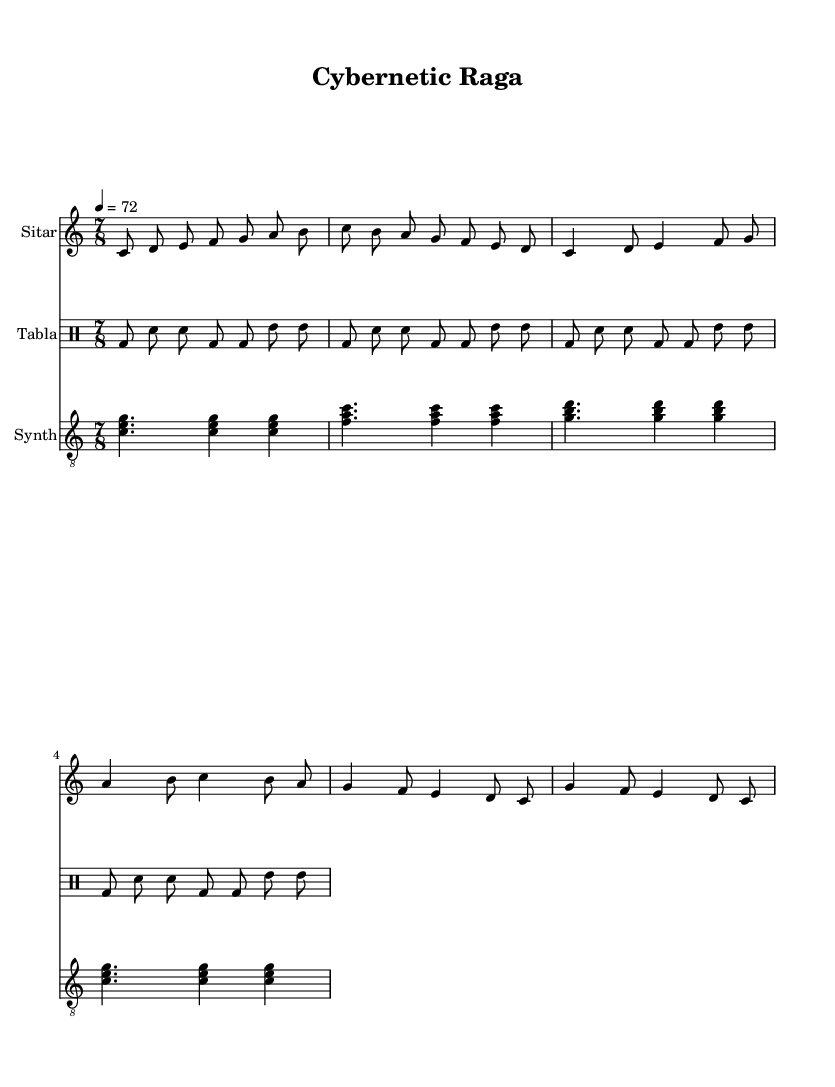What is the key signature of this music? The key signature is indicated at the beginning of the staff and shows that the piece is in C major, which has no sharps or flats.
Answer: C major What is the time signature of this composition? The time signature is displayed at the beginning of the music and is shown as 7/8, indicating that there are seven beats in each measure, and the eighth note gets one beat.
Answer: 7/8 What is the tempo marking for this piece? The tempo marking is found near the beginning of the score, indicating a speed of 72 beats per minute, specified as "4 = 72".
Answer: 72 How many measures are there in the sitar part? Counting the measures in the sitar part shows there are 10 measures at least, considering there are repeated sections.
Answer: 10 What unique rhythmic pattern does the tabla use? The tabla section features a unique pattern of bass drum (bd) and snare (sn) notes, repeated uniformly across eight measures, showcasing traditional rhythms in a contemporary context.
Answer: bd and sn How does the synth complement the sitar? The synth plays sustained chords with various notes that create a harmonic backdrop, using the same underlying key of C major, enhancing the overall texture while allowing the sitar to lead melodically.
Answer: Harmonic backdrop 